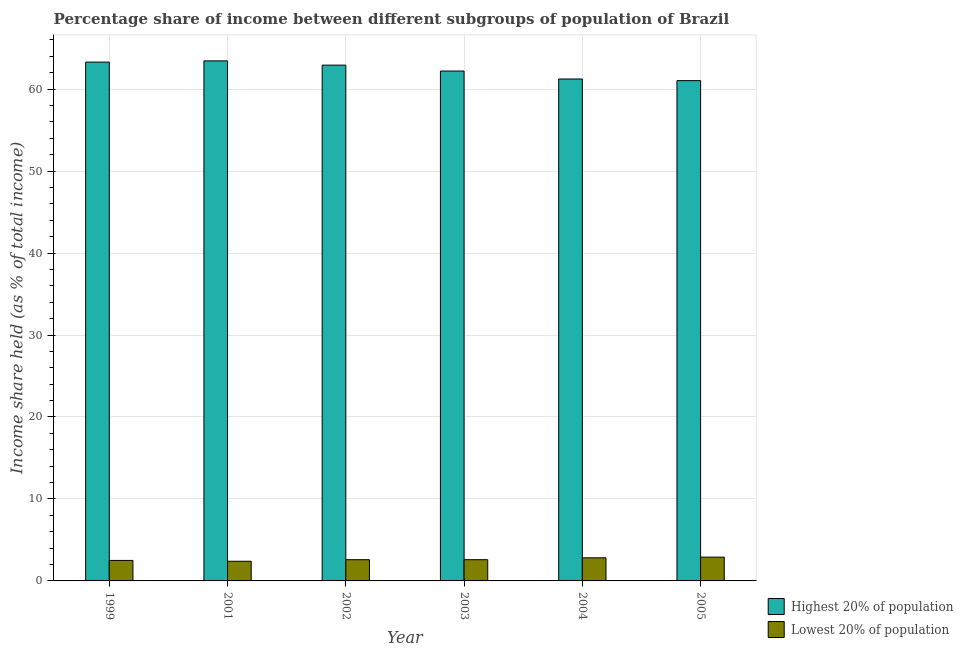How many groups of bars are there?
Offer a terse response. 6. Are the number of bars per tick equal to the number of legend labels?
Your answer should be compact. Yes. How many bars are there on the 2nd tick from the right?
Give a very brief answer. 2. In how many cases, is the number of bars for a given year not equal to the number of legend labels?
Make the answer very short. 0. Across all years, what is the maximum income share held by highest 20% of the population?
Your answer should be compact. 63.45. Across all years, what is the minimum income share held by highest 20% of the population?
Offer a terse response. 61.04. In which year was the income share held by lowest 20% of the population maximum?
Keep it short and to the point. 2005. In which year was the income share held by lowest 20% of the population minimum?
Your response must be concise. 2001. What is the total income share held by lowest 20% of the population in the graph?
Your answer should be compact. 15.8. What is the difference between the income share held by highest 20% of the population in 2003 and that in 2004?
Ensure brevity in your answer.  0.97. What is the difference between the income share held by highest 20% of the population in 2001 and the income share held by lowest 20% of the population in 2003?
Provide a short and direct response. 1.24. What is the average income share held by highest 20% of the population per year?
Give a very brief answer. 62.36. What is the ratio of the income share held by highest 20% of the population in 2004 to that in 2005?
Ensure brevity in your answer.  1. Is the income share held by lowest 20% of the population in 1999 less than that in 2002?
Make the answer very short. Yes. What is the difference between the highest and the second highest income share held by lowest 20% of the population?
Provide a short and direct response. 0.08. In how many years, is the income share held by lowest 20% of the population greater than the average income share held by lowest 20% of the population taken over all years?
Your answer should be very brief. 2. Is the sum of the income share held by lowest 20% of the population in 2002 and 2004 greater than the maximum income share held by highest 20% of the population across all years?
Keep it short and to the point. Yes. What does the 1st bar from the left in 2005 represents?
Your answer should be compact. Highest 20% of population. What does the 2nd bar from the right in 2005 represents?
Make the answer very short. Highest 20% of population. Are all the bars in the graph horizontal?
Offer a very short reply. No. What is the difference between two consecutive major ticks on the Y-axis?
Offer a very short reply. 10. Are the values on the major ticks of Y-axis written in scientific E-notation?
Your answer should be very brief. No. Where does the legend appear in the graph?
Your response must be concise. Bottom right. How many legend labels are there?
Provide a succinct answer. 2. How are the legend labels stacked?
Your response must be concise. Vertical. What is the title of the graph?
Ensure brevity in your answer.  Percentage share of income between different subgroups of population of Brazil. Does "Lower secondary rate" appear as one of the legend labels in the graph?
Offer a very short reply. No. What is the label or title of the Y-axis?
Ensure brevity in your answer.  Income share held (as % of total income). What is the Income share held (as % of total income) in Highest 20% of population in 1999?
Your answer should be very brief. 63.3. What is the Income share held (as % of total income) of Lowest 20% of population in 1999?
Offer a very short reply. 2.5. What is the Income share held (as % of total income) of Highest 20% of population in 2001?
Ensure brevity in your answer.  63.45. What is the Income share held (as % of total income) of Lowest 20% of population in 2001?
Provide a succinct answer. 2.4. What is the Income share held (as % of total income) in Highest 20% of population in 2002?
Your answer should be compact. 62.93. What is the Income share held (as % of total income) of Lowest 20% of population in 2002?
Provide a succinct answer. 2.59. What is the Income share held (as % of total income) of Highest 20% of population in 2003?
Offer a very short reply. 62.21. What is the Income share held (as % of total income) of Lowest 20% of population in 2003?
Provide a succinct answer. 2.59. What is the Income share held (as % of total income) of Highest 20% of population in 2004?
Make the answer very short. 61.24. What is the Income share held (as % of total income) of Lowest 20% of population in 2004?
Your answer should be very brief. 2.82. What is the Income share held (as % of total income) of Highest 20% of population in 2005?
Your response must be concise. 61.04. Across all years, what is the maximum Income share held (as % of total income) of Highest 20% of population?
Provide a short and direct response. 63.45. Across all years, what is the minimum Income share held (as % of total income) of Highest 20% of population?
Make the answer very short. 61.04. What is the total Income share held (as % of total income) in Highest 20% of population in the graph?
Offer a terse response. 374.17. What is the total Income share held (as % of total income) of Lowest 20% of population in the graph?
Your answer should be very brief. 15.8. What is the difference between the Income share held (as % of total income) in Highest 20% of population in 1999 and that in 2001?
Provide a succinct answer. -0.15. What is the difference between the Income share held (as % of total income) of Lowest 20% of population in 1999 and that in 2001?
Ensure brevity in your answer.  0.1. What is the difference between the Income share held (as % of total income) in Highest 20% of population in 1999 and that in 2002?
Your response must be concise. 0.37. What is the difference between the Income share held (as % of total income) of Lowest 20% of population in 1999 and that in 2002?
Your answer should be compact. -0.09. What is the difference between the Income share held (as % of total income) in Highest 20% of population in 1999 and that in 2003?
Your answer should be compact. 1.09. What is the difference between the Income share held (as % of total income) in Lowest 20% of population in 1999 and that in 2003?
Keep it short and to the point. -0.09. What is the difference between the Income share held (as % of total income) in Highest 20% of population in 1999 and that in 2004?
Your answer should be compact. 2.06. What is the difference between the Income share held (as % of total income) in Lowest 20% of population in 1999 and that in 2004?
Provide a short and direct response. -0.32. What is the difference between the Income share held (as % of total income) of Highest 20% of population in 1999 and that in 2005?
Make the answer very short. 2.26. What is the difference between the Income share held (as % of total income) of Highest 20% of population in 2001 and that in 2002?
Your answer should be compact. 0.52. What is the difference between the Income share held (as % of total income) of Lowest 20% of population in 2001 and that in 2002?
Make the answer very short. -0.19. What is the difference between the Income share held (as % of total income) in Highest 20% of population in 2001 and that in 2003?
Your answer should be very brief. 1.24. What is the difference between the Income share held (as % of total income) in Lowest 20% of population in 2001 and that in 2003?
Keep it short and to the point. -0.19. What is the difference between the Income share held (as % of total income) of Highest 20% of population in 2001 and that in 2004?
Your response must be concise. 2.21. What is the difference between the Income share held (as % of total income) of Lowest 20% of population in 2001 and that in 2004?
Your answer should be very brief. -0.42. What is the difference between the Income share held (as % of total income) of Highest 20% of population in 2001 and that in 2005?
Provide a succinct answer. 2.41. What is the difference between the Income share held (as % of total income) in Highest 20% of population in 2002 and that in 2003?
Your response must be concise. 0.72. What is the difference between the Income share held (as % of total income) in Highest 20% of population in 2002 and that in 2004?
Offer a terse response. 1.69. What is the difference between the Income share held (as % of total income) of Lowest 20% of population in 2002 and that in 2004?
Your answer should be compact. -0.23. What is the difference between the Income share held (as % of total income) in Highest 20% of population in 2002 and that in 2005?
Your answer should be very brief. 1.89. What is the difference between the Income share held (as % of total income) of Lowest 20% of population in 2002 and that in 2005?
Your answer should be compact. -0.31. What is the difference between the Income share held (as % of total income) in Lowest 20% of population in 2003 and that in 2004?
Provide a short and direct response. -0.23. What is the difference between the Income share held (as % of total income) in Highest 20% of population in 2003 and that in 2005?
Offer a terse response. 1.17. What is the difference between the Income share held (as % of total income) of Lowest 20% of population in 2003 and that in 2005?
Make the answer very short. -0.31. What is the difference between the Income share held (as % of total income) of Lowest 20% of population in 2004 and that in 2005?
Offer a terse response. -0.08. What is the difference between the Income share held (as % of total income) of Highest 20% of population in 1999 and the Income share held (as % of total income) of Lowest 20% of population in 2001?
Your answer should be compact. 60.9. What is the difference between the Income share held (as % of total income) in Highest 20% of population in 1999 and the Income share held (as % of total income) in Lowest 20% of population in 2002?
Provide a short and direct response. 60.71. What is the difference between the Income share held (as % of total income) of Highest 20% of population in 1999 and the Income share held (as % of total income) of Lowest 20% of population in 2003?
Offer a very short reply. 60.71. What is the difference between the Income share held (as % of total income) in Highest 20% of population in 1999 and the Income share held (as % of total income) in Lowest 20% of population in 2004?
Give a very brief answer. 60.48. What is the difference between the Income share held (as % of total income) of Highest 20% of population in 1999 and the Income share held (as % of total income) of Lowest 20% of population in 2005?
Offer a very short reply. 60.4. What is the difference between the Income share held (as % of total income) of Highest 20% of population in 2001 and the Income share held (as % of total income) of Lowest 20% of population in 2002?
Your answer should be compact. 60.86. What is the difference between the Income share held (as % of total income) of Highest 20% of population in 2001 and the Income share held (as % of total income) of Lowest 20% of population in 2003?
Provide a short and direct response. 60.86. What is the difference between the Income share held (as % of total income) of Highest 20% of population in 2001 and the Income share held (as % of total income) of Lowest 20% of population in 2004?
Your answer should be very brief. 60.63. What is the difference between the Income share held (as % of total income) in Highest 20% of population in 2001 and the Income share held (as % of total income) in Lowest 20% of population in 2005?
Ensure brevity in your answer.  60.55. What is the difference between the Income share held (as % of total income) in Highest 20% of population in 2002 and the Income share held (as % of total income) in Lowest 20% of population in 2003?
Offer a terse response. 60.34. What is the difference between the Income share held (as % of total income) of Highest 20% of population in 2002 and the Income share held (as % of total income) of Lowest 20% of population in 2004?
Your answer should be very brief. 60.11. What is the difference between the Income share held (as % of total income) of Highest 20% of population in 2002 and the Income share held (as % of total income) of Lowest 20% of population in 2005?
Keep it short and to the point. 60.03. What is the difference between the Income share held (as % of total income) in Highest 20% of population in 2003 and the Income share held (as % of total income) in Lowest 20% of population in 2004?
Offer a very short reply. 59.39. What is the difference between the Income share held (as % of total income) of Highest 20% of population in 2003 and the Income share held (as % of total income) of Lowest 20% of population in 2005?
Your response must be concise. 59.31. What is the difference between the Income share held (as % of total income) of Highest 20% of population in 2004 and the Income share held (as % of total income) of Lowest 20% of population in 2005?
Your answer should be compact. 58.34. What is the average Income share held (as % of total income) in Highest 20% of population per year?
Provide a succinct answer. 62.36. What is the average Income share held (as % of total income) of Lowest 20% of population per year?
Offer a very short reply. 2.63. In the year 1999, what is the difference between the Income share held (as % of total income) in Highest 20% of population and Income share held (as % of total income) in Lowest 20% of population?
Provide a short and direct response. 60.8. In the year 2001, what is the difference between the Income share held (as % of total income) of Highest 20% of population and Income share held (as % of total income) of Lowest 20% of population?
Your answer should be compact. 61.05. In the year 2002, what is the difference between the Income share held (as % of total income) in Highest 20% of population and Income share held (as % of total income) in Lowest 20% of population?
Your answer should be compact. 60.34. In the year 2003, what is the difference between the Income share held (as % of total income) in Highest 20% of population and Income share held (as % of total income) in Lowest 20% of population?
Your response must be concise. 59.62. In the year 2004, what is the difference between the Income share held (as % of total income) in Highest 20% of population and Income share held (as % of total income) in Lowest 20% of population?
Offer a very short reply. 58.42. In the year 2005, what is the difference between the Income share held (as % of total income) of Highest 20% of population and Income share held (as % of total income) of Lowest 20% of population?
Make the answer very short. 58.14. What is the ratio of the Income share held (as % of total income) of Highest 20% of population in 1999 to that in 2001?
Your response must be concise. 1. What is the ratio of the Income share held (as % of total income) of Lowest 20% of population in 1999 to that in 2001?
Ensure brevity in your answer.  1.04. What is the ratio of the Income share held (as % of total income) in Highest 20% of population in 1999 to that in 2002?
Keep it short and to the point. 1.01. What is the ratio of the Income share held (as % of total income) of Lowest 20% of population in 1999 to that in 2002?
Your answer should be compact. 0.97. What is the ratio of the Income share held (as % of total income) of Highest 20% of population in 1999 to that in 2003?
Offer a terse response. 1.02. What is the ratio of the Income share held (as % of total income) of Lowest 20% of population in 1999 to that in 2003?
Keep it short and to the point. 0.97. What is the ratio of the Income share held (as % of total income) in Highest 20% of population in 1999 to that in 2004?
Your answer should be compact. 1.03. What is the ratio of the Income share held (as % of total income) of Lowest 20% of population in 1999 to that in 2004?
Keep it short and to the point. 0.89. What is the ratio of the Income share held (as % of total income) of Highest 20% of population in 1999 to that in 2005?
Offer a very short reply. 1.04. What is the ratio of the Income share held (as % of total income) of Lowest 20% of population in 1999 to that in 2005?
Your response must be concise. 0.86. What is the ratio of the Income share held (as % of total income) in Highest 20% of population in 2001 to that in 2002?
Ensure brevity in your answer.  1.01. What is the ratio of the Income share held (as % of total income) in Lowest 20% of population in 2001 to that in 2002?
Ensure brevity in your answer.  0.93. What is the ratio of the Income share held (as % of total income) in Highest 20% of population in 2001 to that in 2003?
Provide a short and direct response. 1.02. What is the ratio of the Income share held (as % of total income) in Lowest 20% of population in 2001 to that in 2003?
Make the answer very short. 0.93. What is the ratio of the Income share held (as % of total income) in Highest 20% of population in 2001 to that in 2004?
Ensure brevity in your answer.  1.04. What is the ratio of the Income share held (as % of total income) in Lowest 20% of population in 2001 to that in 2004?
Your response must be concise. 0.85. What is the ratio of the Income share held (as % of total income) in Highest 20% of population in 2001 to that in 2005?
Make the answer very short. 1.04. What is the ratio of the Income share held (as % of total income) of Lowest 20% of population in 2001 to that in 2005?
Offer a terse response. 0.83. What is the ratio of the Income share held (as % of total income) in Highest 20% of population in 2002 to that in 2003?
Your response must be concise. 1.01. What is the ratio of the Income share held (as % of total income) of Lowest 20% of population in 2002 to that in 2003?
Keep it short and to the point. 1. What is the ratio of the Income share held (as % of total income) in Highest 20% of population in 2002 to that in 2004?
Provide a succinct answer. 1.03. What is the ratio of the Income share held (as % of total income) of Lowest 20% of population in 2002 to that in 2004?
Provide a succinct answer. 0.92. What is the ratio of the Income share held (as % of total income) of Highest 20% of population in 2002 to that in 2005?
Your response must be concise. 1.03. What is the ratio of the Income share held (as % of total income) of Lowest 20% of population in 2002 to that in 2005?
Keep it short and to the point. 0.89. What is the ratio of the Income share held (as % of total income) of Highest 20% of population in 2003 to that in 2004?
Provide a short and direct response. 1.02. What is the ratio of the Income share held (as % of total income) in Lowest 20% of population in 2003 to that in 2004?
Offer a terse response. 0.92. What is the ratio of the Income share held (as % of total income) in Highest 20% of population in 2003 to that in 2005?
Ensure brevity in your answer.  1.02. What is the ratio of the Income share held (as % of total income) of Lowest 20% of population in 2003 to that in 2005?
Give a very brief answer. 0.89. What is the ratio of the Income share held (as % of total income) in Lowest 20% of population in 2004 to that in 2005?
Your answer should be compact. 0.97. What is the difference between the highest and the lowest Income share held (as % of total income) of Highest 20% of population?
Your response must be concise. 2.41. 